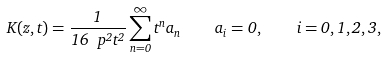Convert formula to latex. <formula><loc_0><loc_0><loc_500><loc_500>K ( z , t ) = \frac { 1 } { 1 6 \ p ^ { 2 } t ^ { 2 } } \sum _ { n = 0 } ^ { \infty } t ^ { n } a _ { n } \quad a _ { i } = 0 , \quad i = 0 , 1 , 2 , 3 ,</formula> 